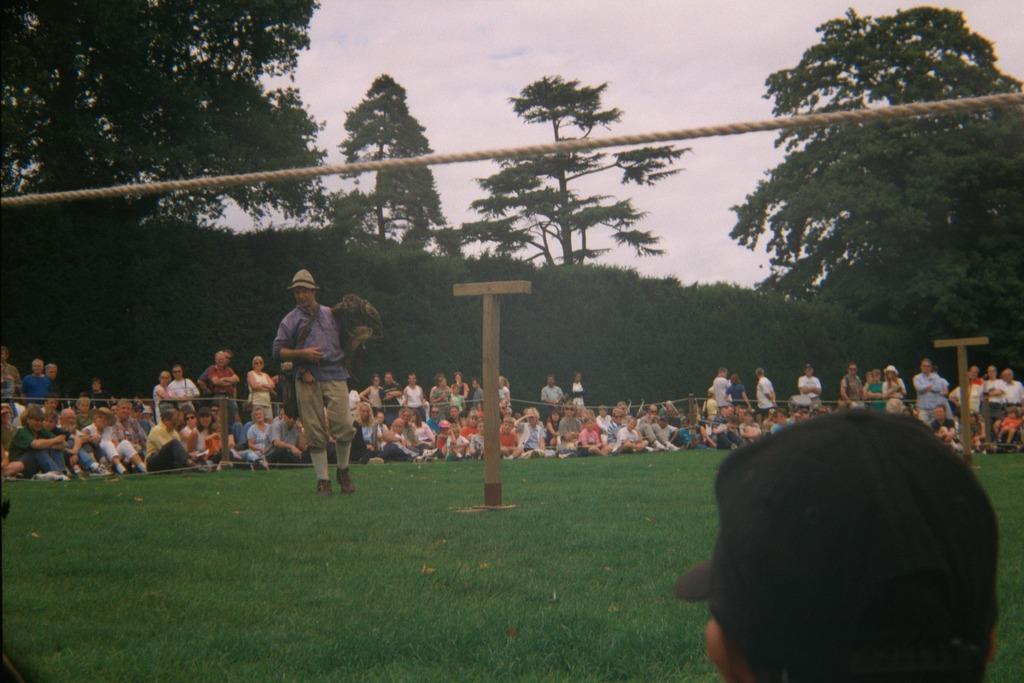Can you describe this image briefly? In this picture there is a man who is holding a monkey. He is standing on the ground, beside that there is a bamboo. At the bottom we can see grass. In back side we can see the group of persons were standing and sitting. In the background we can see the group of persons were watching this show. In the background we can see the plants and trees. At the top we can see sky and clouds. 